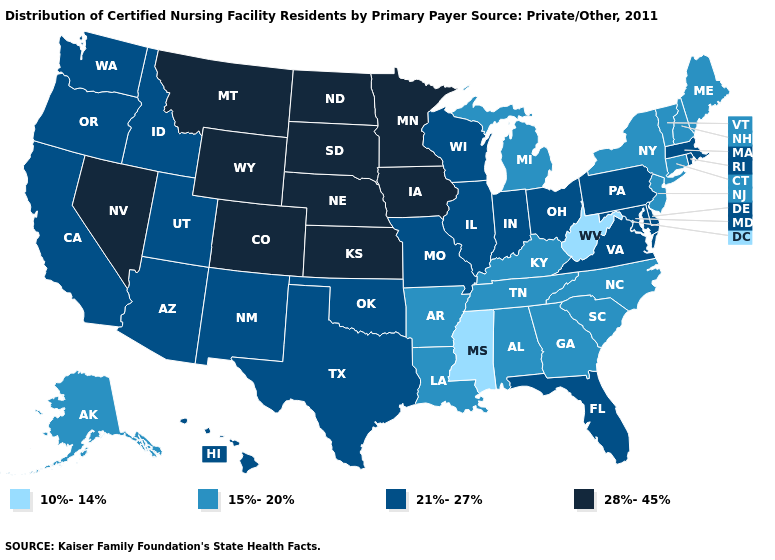Name the states that have a value in the range 21%-27%?
Answer briefly. Arizona, California, Delaware, Florida, Hawaii, Idaho, Illinois, Indiana, Maryland, Massachusetts, Missouri, New Mexico, Ohio, Oklahoma, Oregon, Pennsylvania, Rhode Island, Texas, Utah, Virginia, Washington, Wisconsin. What is the value of Georgia?
Be succinct. 15%-20%. What is the value of Washington?
Concise answer only. 21%-27%. What is the value of Nevada?
Answer briefly. 28%-45%. What is the value of Oklahoma?
Give a very brief answer. 21%-27%. Among the states that border New York , which have the highest value?
Concise answer only. Massachusetts, Pennsylvania. Name the states that have a value in the range 21%-27%?
Give a very brief answer. Arizona, California, Delaware, Florida, Hawaii, Idaho, Illinois, Indiana, Maryland, Massachusetts, Missouri, New Mexico, Ohio, Oklahoma, Oregon, Pennsylvania, Rhode Island, Texas, Utah, Virginia, Washington, Wisconsin. What is the value of South Dakota?
Quick response, please. 28%-45%. Among the states that border Wyoming , does Colorado have the highest value?
Be succinct. Yes. Name the states that have a value in the range 21%-27%?
Keep it brief. Arizona, California, Delaware, Florida, Hawaii, Idaho, Illinois, Indiana, Maryland, Massachusetts, Missouri, New Mexico, Ohio, Oklahoma, Oregon, Pennsylvania, Rhode Island, Texas, Utah, Virginia, Washington, Wisconsin. What is the highest value in states that border Alabama?
Write a very short answer. 21%-27%. Among the states that border New Hampshire , does Maine have the highest value?
Write a very short answer. No. Does Maryland have a lower value than Iowa?
Short answer required. Yes. Does Oregon have the highest value in the West?
Concise answer only. No. Does Missouri have a higher value than New Jersey?
Be succinct. Yes. 